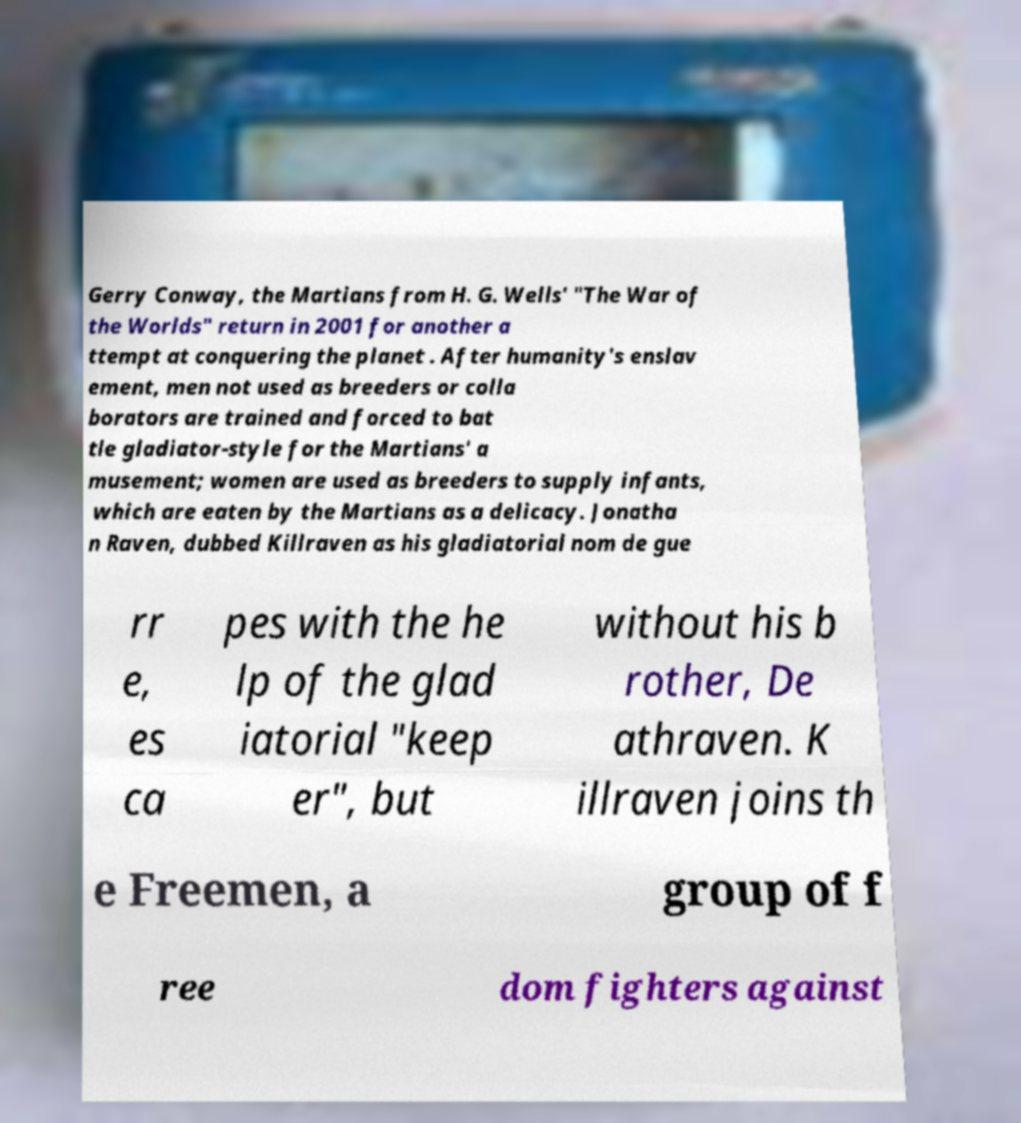There's text embedded in this image that I need extracted. Can you transcribe it verbatim? Gerry Conway, the Martians from H. G. Wells' "The War of the Worlds" return in 2001 for another a ttempt at conquering the planet . After humanity's enslav ement, men not used as breeders or colla borators are trained and forced to bat tle gladiator-style for the Martians' a musement; women are used as breeders to supply infants, which are eaten by the Martians as a delicacy. Jonatha n Raven, dubbed Killraven as his gladiatorial nom de gue rr e, es ca pes with the he lp of the glad iatorial "keep er", but without his b rother, De athraven. K illraven joins th e Freemen, a group of f ree dom fighters against 